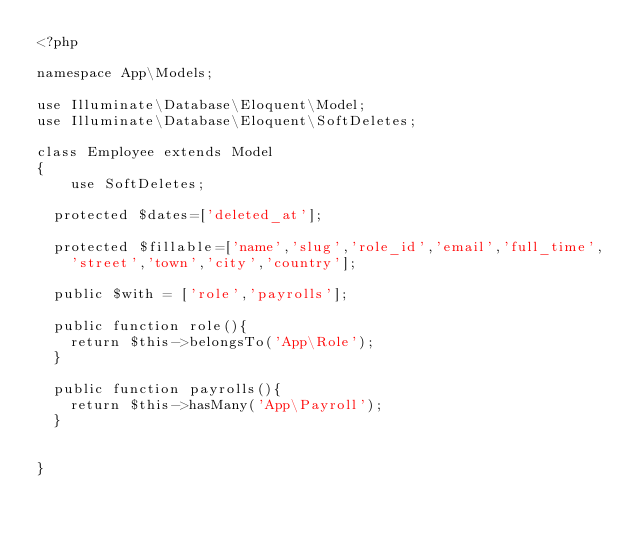Convert code to text. <code><loc_0><loc_0><loc_500><loc_500><_PHP_><?php

namespace App\Models;

use Illuminate\Database\Eloquent\Model;
use Illuminate\Database\Eloquent\SoftDeletes;

class Employee extends Model
{
    use SoftDeletes;
	
	protected $dates=['deleted_at'];
	
	protected $fillable=['name','slug','role_id','email','full_time',
		'street','town','city','country'];
	
	public $with = ['role','payrolls'];
	
	public function role(){
		return $this->belongsTo('App\Role');
	}
	
	public function payrolls(){
		return $this->hasMany('App\Payroll');
	}
	
	
}
</code> 